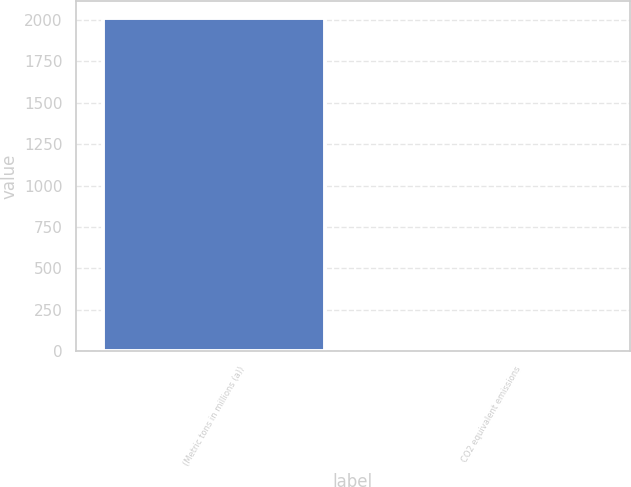Convert chart. <chart><loc_0><loc_0><loc_500><loc_500><bar_chart><fcel>(Metric tons in millions (a))<fcel>CO2 equivalent emissions<nl><fcel>2013<fcel>3.4<nl></chart> 